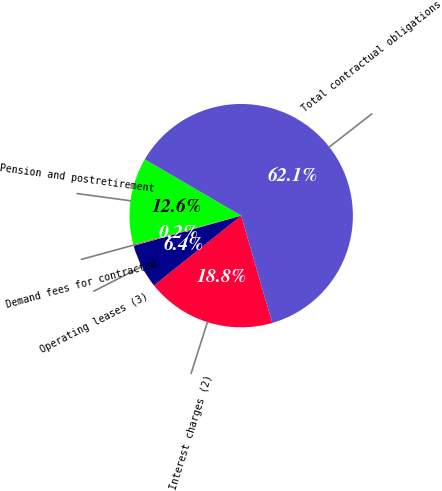Convert chart. <chart><loc_0><loc_0><loc_500><loc_500><pie_chart><fcel>Interest charges (2)<fcel>Operating leases (3)<fcel>Demand fees for contracted<fcel>Pension and postretirement<fcel>Total contractual obligations<nl><fcel>18.76%<fcel>6.38%<fcel>0.19%<fcel>12.57%<fcel>62.09%<nl></chart> 